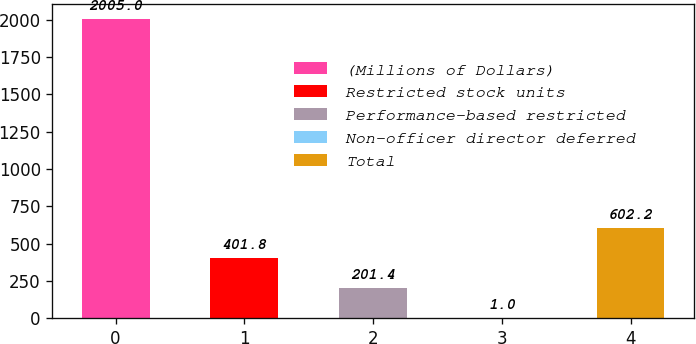Convert chart to OTSL. <chart><loc_0><loc_0><loc_500><loc_500><bar_chart><fcel>(Millions of Dollars)<fcel>Restricted stock units<fcel>Performance-based restricted<fcel>Non-officer director deferred<fcel>Total<nl><fcel>2005<fcel>401.8<fcel>201.4<fcel>1<fcel>602.2<nl></chart> 